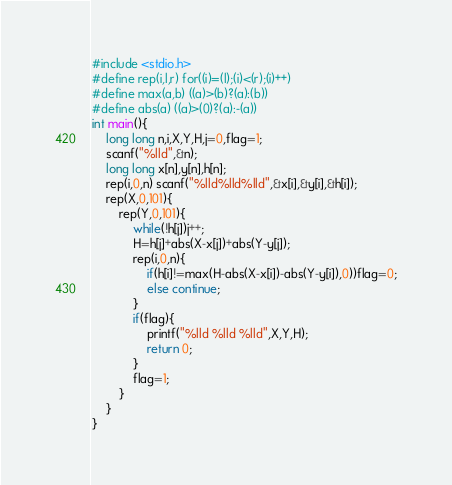<code> <loc_0><loc_0><loc_500><loc_500><_C_>#include <stdio.h>
#define rep(i,l,r) for((i)=(l);(i)<(r);(i)++)
#define max(a,b) ((a)>(b)?(a):(b))
#define abs(a) ((a)>(0)?(a):-(a))
int main(){
    long long n,i,X,Y,H,j=0,flag=1;
    scanf("%lld",&n);
    long long x[n],y[n],h[n];
    rep(i,0,n) scanf("%lld%lld%lld",&x[i],&y[i],&h[i]);
    rep(X,0,101){
        rep(Y,0,101){
            while(!h[j])j++;
            H=h[j]+abs(X-x[j])+abs(Y-y[j]);
            rep(i,0,n){
                if(h[i]!=max(H-abs(X-x[i])-abs(Y-y[i]),0))flag=0;
                else continue;
            }
            if(flag){
                printf("%lld %lld %lld",X,Y,H);
                return 0;
            }
            flag=1;
        }
    }
}</code> 